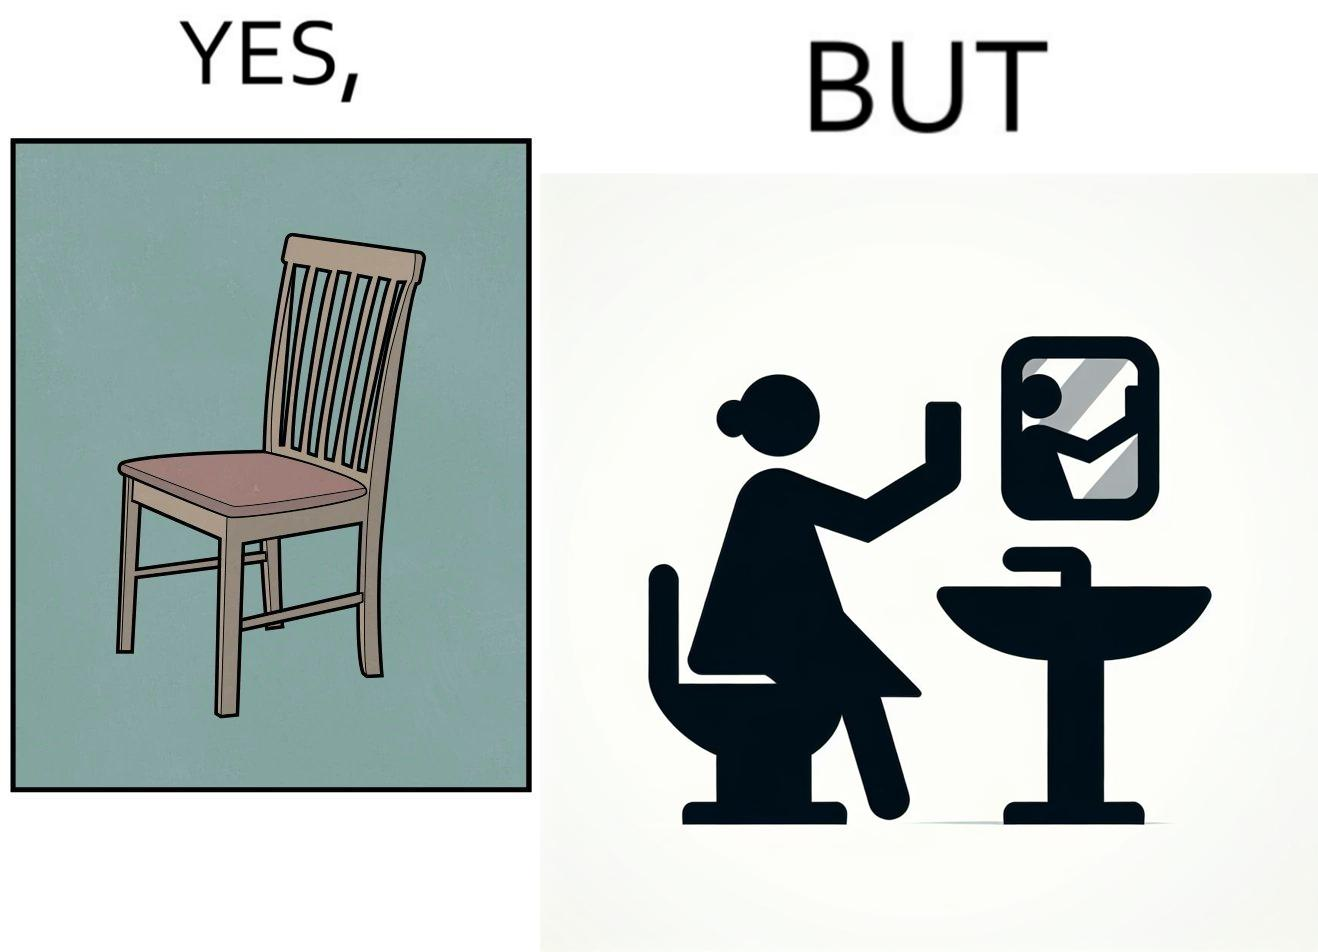Is there satirical content in this image? Yes, this image is satirical. 